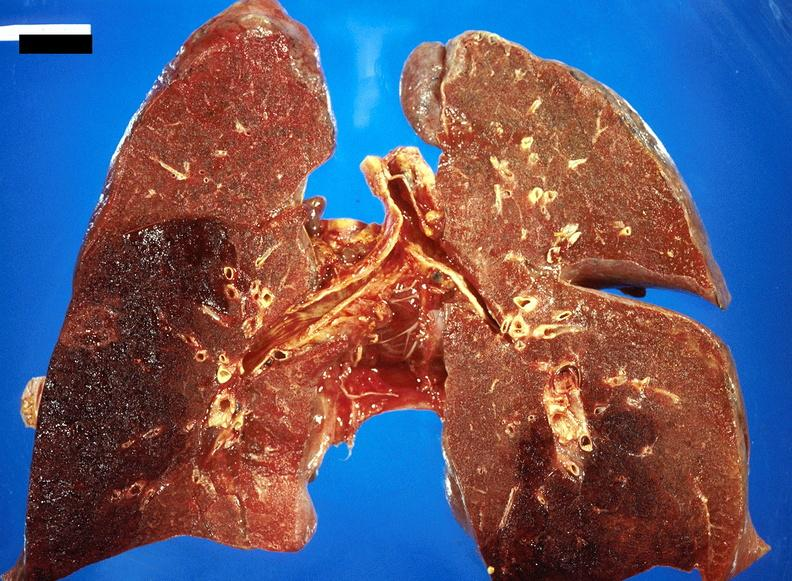s respiratory present?
Answer the question using a single word or phrase. Yes 